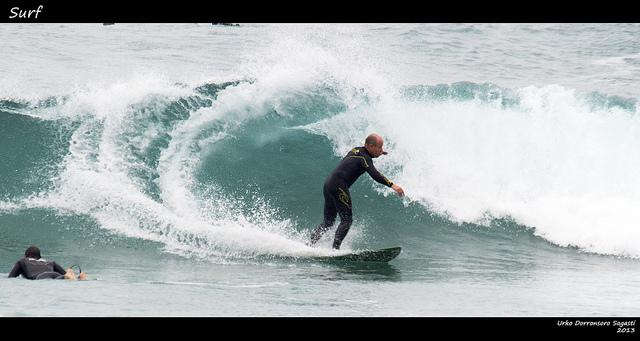What type of hairline does the standing man have? Please explain your reasoning. receding. He is losing his hair and you can see it's farther back on his head. 